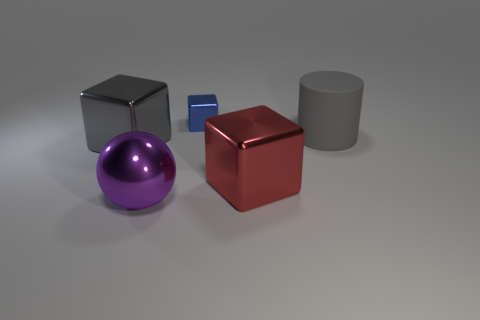Is there anything else that has the same size as the blue object?
Your answer should be very brief. No. What is the color of the shiny thing that is on the right side of the metallic cube that is behind the large gray cylinder?
Your answer should be very brief. Red. What material is the big gray thing that is behind the metallic block to the left of the small shiny block?
Your response must be concise. Rubber. What material is the gray thing that is the same shape as the small blue metallic object?
Offer a very short reply. Metal. There is a large shiny cube that is behind the large cube that is in front of the gray shiny cube; are there any tiny cubes that are right of it?
Offer a terse response. Yes. What number of other things are there of the same color as the matte cylinder?
Your answer should be very brief. 1. How many metallic objects are behind the big metallic sphere and left of the red block?
Keep it short and to the point. 2. The blue thing has what shape?
Make the answer very short. Cube. How many other objects are the same material as the big red block?
Your answer should be compact. 3. There is a metallic cube that is on the left side of the object that is behind the large gray object to the right of the big red shiny block; what is its color?
Your response must be concise. Gray. 